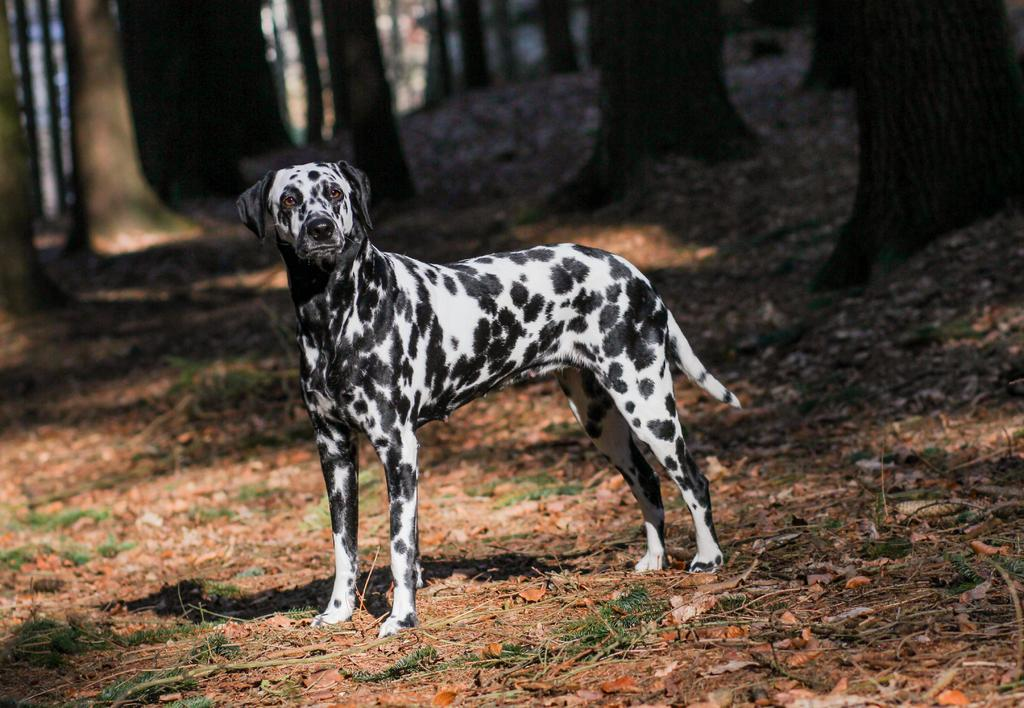What type of animal is present in the image? There is a dog in the image. What color scheme is used for the dog in the image? The dog is in black and white color. What type of natural scenery can be seen in the image? There are trees visible at the top of the image. How does the dog start the digestion process in the image? The image does not show the dog in the process of digestion, so it cannot be determined from the image. 